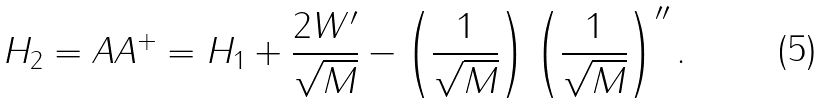<formula> <loc_0><loc_0><loc_500><loc_500>H _ { 2 } = A A ^ { + } = H _ { 1 } + \frac { 2 W ^ { \prime } } { \sqrt { M } } - \left ( \frac { 1 } { \sqrt { M } } \right ) \left ( \frac { 1 } { \sqrt { M } } \right ) ^ { \prime \prime } .</formula> 